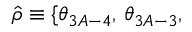Convert formula to latex. <formula><loc_0><loc_0><loc_500><loc_500>\hat { \rho } \equiv \{ \theta _ { 3 A - 4 } , \, \theta _ { 3 A - 3 } ,</formula> 